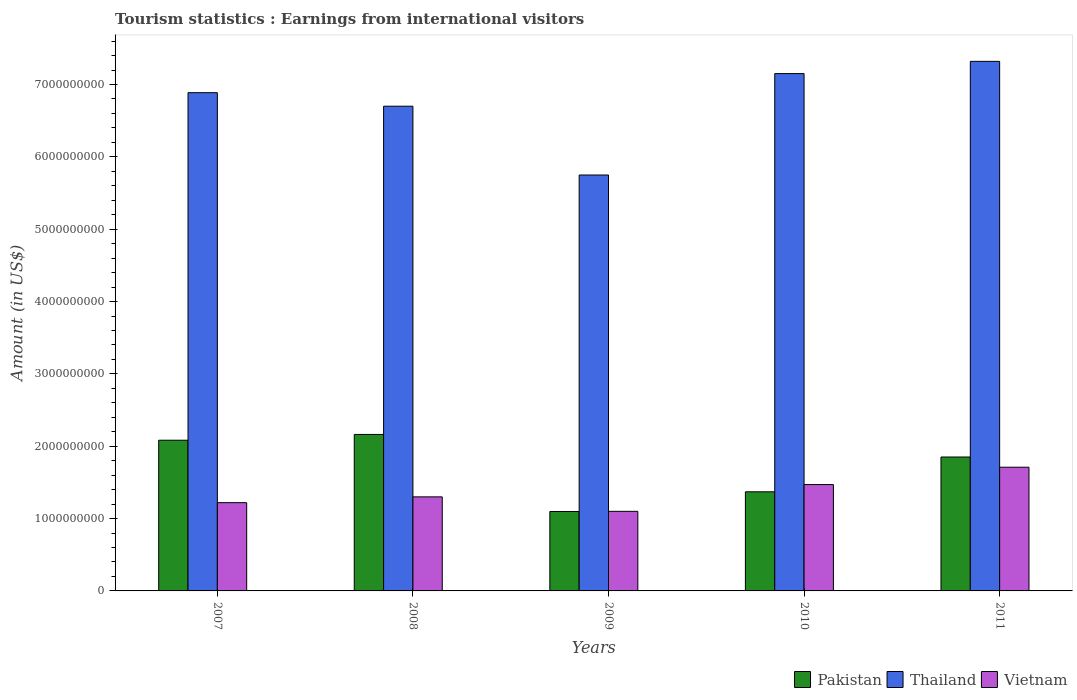How many groups of bars are there?
Your response must be concise. 5. What is the label of the 3rd group of bars from the left?
Your response must be concise. 2009. What is the earnings from international visitors in Pakistan in 2008?
Give a very brief answer. 2.16e+09. Across all years, what is the maximum earnings from international visitors in Thailand?
Ensure brevity in your answer.  7.32e+09. Across all years, what is the minimum earnings from international visitors in Pakistan?
Your response must be concise. 1.10e+09. In which year was the earnings from international visitors in Pakistan maximum?
Offer a terse response. 2008. What is the total earnings from international visitors in Pakistan in the graph?
Keep it short and to the point. 8.56e+09. What is the difference between the earnings from international visitors in Vietnam in 2010 and that in 2011?
Your answer should be very brief. -2.40e+08. What is the difference between the earnings from international visitors in Thailand in 2008 and the earnings from international visitors in Pakistan in 2007?
Ensure brevity in your answer.  4.62e+09. What is the average earnings from international visitors in Vietnam per year?
Provide a short and direct response. 1.36e+09. In the year 2009, what is the difference between the earnings from international visitors in Vietnam and earnings from international visitors in Thailand?
Your answer should be compact. -4.65e+09. In how many years, is the earnings from international visitors in Thailand greater than 3800000000 US$?
Offer a very short reply. 5. What is the ratio of the earnings from international visitors in Vietnam in 2009 to that in 2010?
Provide a succinct answer. 0.75. Is the earnings from international visitors in Pakistan in 2007 less than that in 2010?
Your answer should be compact. No. What is the difference between the highest and the second highest earnings from international visitors in Thailand?
Keep it short and to the point. 1.69e+08. What is the difference between the highest and the lowest earnings from international visitors in Pakistan?
Provide a short and direct response. 1.06e+09. In how many years, is the earnings from international visitors in Thailand greater than the average earnings from international visitors in Thailand taken over all years?
Give a very brief answer. 3. Is the sum of the earnings from international visitors in Pakistan in 2007 and 2011 greater than the maximum earnings from international visitors in Vietnam across all years?
Your answer should be very brief. Yes. What does the 3rd bar from the left in 2011 represents?
Ensure brevity in your answer.  Vietnam. What does the 1st bar from the right in 2011 represents?
Keep it short and to the point. Vietnam. Is it the case that in every year, the sum of the earnings from international visitors in Vietnam and earnings from international visitors in Pakistan is greater than the earnings from international visitors in Thailand?
Provide a succinct answer. No. How many years are there in the graph?
Your answer should be very brief. 5. Does the graph contain any zero values?
Your response must be concise. No. How many legend labels are there?
Offer a terse response. 3. How are the legend labels stacked?
Your answer should be compact. Horizontal. What is the title of the graph?
Ensure brevity in your answer.  Tourism statistics : Earnings from international visitors. Does "Macao" appear as one of the legend labels in the graph?
Offer a very short reply. No. What is the label or title of the X-axis?
Give a very brief answer. Years. What is the label or title of the Y-axis?
Provide a succinct answer. Amount (in US$). What is the Amount (in US$) of Pakistan in 2007?
Give a very brief answer. 2.08e+09. What is the Amount (in US$) of Thailand in 2007?
Provide a succinct answer. 6.89e+09. What is the Amount (in US$) of Vietnam in 2007?
Keep it short and to the point. 1.22e+09. What is the Amount (in US$) of Pakistan in 2008?
Provide a succinct answer. 2.16e+09. What is the Amount (in US$) in Thailand in 2008?
Ensure brevity in your answer.  6.70e+09. What is the Amount (in US$) in Vietnam in 2008?
Offer a terse response. 1.30e+09. What is the Amount (in US$) in Pakistan in 2009?
Your response must be concise. 1.10e+09. What is the Amount (in US$) in Thailand in 2009?
Make the answer very short. 5.75e+09. What is the Amount (in US$) in Vietnam in 2009?
Ensure brevity in your answer.  1.10e+09. What is the Amount (in US$) in Pakistan in 2010?
Keep it short and to the point. 1.37e+09. What is the Amount (in US$) of Thailand in 2010?
Make the answer very short. 7.15e+09. What is the Amount (in US$) of Vietnam in 2010?
Provide a short and direct response. 1.47e+09. What is the Amount (in US$) in Pakistan in 2011?
Your response must be concise. 1.85e+09. What is the Amount (in US$) in Thailand in 2011?
Your answer should be compact. 7.32e+09. What is the Amount (in US$) of Vietnam in 2011?
Give a very brief answer. 1.71e+09. Across all years, what is the maximum Amount (in US$) in Pakistan?
Keep it short and to the point. 2.16e+09. Across all years, what is the maximum Amount (in US$) of Thailand?
Your answer should be very brief. 7.32e+09. Across all years, what is the maximum Amount (in US$) of Vietnam?
Your response must be concise. 1.71e+09. Across all years, what is the minimum Amount (in US$) of Pakistan?
Make the answer very short. 1.10e+09. Across all years, what is the minimum Amount (in US$) of Thailand?
Your response must be concise. 5.75e+09. Across all years, what is the minimum Amount (in US$) in Vietnam?
Your answer should be compact. 1.10e+09. What is the total Amount (in US$) in Pakistan in the graph?
Make the answer very short. 8.56e+09. What is the total Amount (in US$) of Thailand in the graph?
Provide a short and direct response. 3.38e+1. What is the total Amount (in US$) in Vietnam in the graph?
Provide a short and direct response. 6.80e+09. What is the difference between the Amount (in US$) of Pakistan in 2007 and that in 2008?
Your answer should be very brief. -8.00e+07. What is the difference between the Amount (in US$) of Thailand in 2007 and that in 2008?
Your response must be concise. 1.87e+08. What is the difference between the Amount (in US$) of Vietnam in 2007 and that in 2008?
Offer a very short reply. -8.00e+07. What is the difference between the Amount (in US$) of Pakistan in 2007 and that in 2009?
Provide a short and direct response. 9.85e+08. What is the difference between the Amount (in US$) of Thailand in 2007 and that in 2009?
Offer a terse response. 1.14e+09. What is the difference between the Amount (in US$) of Vietnam in 2007 and that in 2009?
Ensure brevity in your answer.  1.20e+08. What is the difference between the Amount (in US$) in Pakistan in 2007 and that in 2010?
Make the answer very short. 7.13e+08. What is the difference between the Amount (in US$) of Thailand in 2007 and that in 2010?
Your answer should be very brief. -2.64e+08. What is the difference between the Amount (in US$) in Vietnam in 2007 and that in 2010?
Ensure brevity in your answer.  -2.50e+08. What is the difference between the Amount (in US$) of Pakistan in 2007 and that in 2011?
Provide a short and direct response. 2.32e+08. What is the difference between the Amount (in US$) in Thailand in 2007 and that in 2011?
Provide a succinct answer. -4.33e+08. What is the difference between the Amount (in US$) in Vietnam in 2007 and that in 2011?
Provide a short and direct response. -4.90e+08. What is the difference between the Amount (in US$) in Pakistan in 2008 and that in 2009?
Keep it short and to the point. 1.06e+09. What is the difference between the Amount (in US$) in Thailand in 2008 and that in 2009?
Ensure brevity in your answer.  9.51e+08. What is the difference between the Amount (in US$) in Vietnam in 2008 and that in 2009?
Your answer should be very brief. 2.00e+08. What is the difference between the Amount (in US$) in Pakistan in 2008 and that in 2010?
Your answer should be compact. 7.93e+08. What is the difference between the Amount (in US$) in Thailand in 2008 and that in 2010?
Your response must be concise. -4.51e+08. What is the difference between the Amount (in US$) in Vietnam in 2008 and that in 2010?
Ensure brevity in your answer.  -1.70e+08. What is the difference between the Amount (in US$) of Pakistan in 2008 and that in 2011?
Provide a short and direct response. 3.12e+08. What is the difference between the Amount (in US$) in Thailand in 2008 and that in 2011?
Keep it short and to the point. -6.20e+08. What is the difference between the Amount (in US$) of Vietnam in 2008 and that in 2011?
Your response must be concise. -4.10e+08. What is the difference between the Amount (in US$) of Pakistan in 2009 and that in 2010?
Offer a very short reply. -2.72e+08. What is the difference between the Amount (in US$) in Thailand in 2009 and that in 2010?
Ensure brevity in your answer.  -1.40e+09. What is the difference between the Amount (in US$) of Vietnam in 2009 and that in 2010?
Provide a succinct answer. -3.70e+08. What is the difference between the Amount (in US$) of Pakistan in 2009 and that in 2011?
Your response must be concise. -7.53e+08. What is the difference between the Amount (in US$) in Thailand in 2009 and that in 2011?
Your answer should be compact. -1.57e+09. What is the difference between the Amount (in US$) in Vietnam in 2009 and that in 2011?
Offer a very short reply. -6.10e+08. What is the difference between the Amount (in US$) of Pakistan in 2010 and that in 2011?
Keep it short and to the point. -4.81e+08. What is the difference between the Amount (in US$) in Thailand in 2010 and that in 2011?
Offer a very short reply. -1.69e+08. What is the difference between the Amount (in US$) in Vietnam in 2010 and that in 2011?
Provide a succinct answer. -2.40e+08. What is the difference between the Amount (in US$) of Pakistan in 2007 and the Amount (in US$) of Thailand in 2008?
Provide a succinct answer. -4.62e+09. What is the difference between the Amount (in US$) in Pakistan in 2007 and the Amount (in US$) in Vietnam in 2008?
Keep it short and to the point. 7.83e+08. What is the difference between the Amount (in US$) of Thailand in 2007 and the Amount (in US$) of Vietnam in 2008?
Your answer should be very brief. 5.59e+09. What is the difference between the Amount (in US$) of Pakistan in 2007 and the Amount (in US$) of Thailand in 2009?
Your response must be concise. -3.67e+09. What is the difference between the Amount (in US$) of Pakistan in 2007 and the Amount (in US$) of Vietnam in 2009?
Your response must be concise. 9.83e+08. What is the difference between the Amount (in US$) of Thailand in 2007 and the Amount (in US$) of Vietnam in 2009?
Give a very brief answer. 5.79e+09. What is the difference between the Amount (in US$) of Pakistan in 2007 and the Amount (in US$) of Thailand in 2010?
Provide a short and direct response. -5.07e+09. What is the difference between the Amount (in US$) in Pakistan in 2007 and the Amount (in US$) in Vietnam in 2010?
Offer a very short reply. 6.13e+08. What is the difference between the Amount (in US$) in Thailand in 2007 and the Amount (in US$) in Vietnam in 2010?
Ensure brevity in your answer.  5.42e+09. What is the difference between the Amount (in US$) of Pakistan in 2007 and the Amount (in US$) of Thailand in 2011?
Provide a short and direct response. -5.24e+09. What is the difference between the Amount (in US$) of Pakistan in 2007 and the Amount (in US$) of Vietnam in 2011?
Give a very brief answer. 3.73e+08. What is the difference between the Amount (in US$) of Thailand in 2007 and the Amount (in US$) of Vietnam in 2011?
Ensure brevity in your answer.  5.18e+09. What is the difference between the Amount (in US$) in Pakistan in 2008 and the Amount (in US$) in Thailand in 2009?
Provide a short and direct response. -3.59e+09. What is the difference between the Amount (in US$) in Pakistan in 2008 and the Amount (in US$) in Vietnam in 2009?
Offer a very short reply. 1.06e+09. What is the difference between the Amount (in US$) in Thailand in 2008 and the Amount (in US$) in Vietnam in 2009?
Your answer should be very brief. 5.60e+09. What is the difference between the Amount (in US$) of Pakistan in 2008 and the Amount (in US$) of Thailand in 2010?
Provide a succinct answer. -4.99e+09. What is the difference between the Amount (in US$) of Pakistan in 2008 and the Amount (in US$) of Vietnam in 2010?
Offer a terse response. 6.93e+08. What is the difference between the Amount (in US$) in Thailand in 2008 and the Amount (in US$) in Vietnam in 2010?
Offer a terse response. 5.23e+09. What is the difference between the Amount (in US$) in Pakistan in 2008 and the Amount (in US$) in Thailand in 2011?
Offer a terse response. -5.16e+09. What is the difference between the Amount (in US$) of Pakistan in 2008 and the Amount (in US$) of Vietnam in 2011?
Provide a short and direct response. 4.53e+08. What is the difference between the Amount (in US$) in Thailand in 2008 and the Amount (in US$) in Vietnam in 2011?
Your response must be concise. 4.99e+09. What is the difference between the Amount (in US$) in Pakistan in 2009 and the Amount (in US$) in Thailand in 2010?
Offer a very short reply. -6.05e+09. What is the difference between the Amount (in US$) in Pakistan in 2009 and the Amount (in US$) in Vietnam in 2010?
Provide a short and direct response. -3.72e+08. What is the difference between the Amount (in US$) of Thailand in 2009 and the Amount (in US$) of Vietnam in 2010?
Give a very brief answer. 4.28e+09. What is the difference between the Amount (in US$) of Pakistan in 2009 and the Amount (in US$) of Thailand in 2011?
Offer a very short reply. -6.22e+09. What is the difference between the Amount (in US$) of Pakistan in 2009 and the Amount (in US$) of Vietnam in 2011?
Make the answer very short. -6.12e+08. What is the difference between the Amount (in US$) in Thailand in 2009 and the Amount (in US$) in Vietnam in 2011?
Make the answer very short. 4.04e+09. What is the difference between the Amount (in US$) of Pakistan in 2010 and the Amount (in US$) of Thailand in 2011?
Your answer should be compact. -5.95e+09. What is the difference between the Amount (in US$) of Pakistan in 2010 and the Amount (in US$) of Vietnam in 2011?
Give a very brief answer. -3.40e+08. What is the difference between the Amount (in US$) of Thailand in 2010 and the Amount (in US$) of Vietnam in 2011?
Ensure brevity in your answer.  5.44e+09. What is the average Amount (in US$) of Pakistan per year?
Offer a terse response. 1.71e+09. What is the average Amount (in US$) in Thailand per year?
Give a very brief answer. 6.76e+09. What is the average Amount (in US$) in Vietnam per year?
Provide a succinct answer. 1.36e+09. In the year 2007, what is the difference between the Amount (in US$) in Pakistan and Amount (in US$) in Thailand?
Offer a terse response. -4.80e+09. In the year 2007, what is the difference between the Amount (in US$) of Pakistan and Amount (in US$) of Vietnam?
Your answer should be very brief. 8.63e+08. In the year 2007, what is the difference between the Amount (in US$) in Thailand and Amount (in US$) in Vietnam?
Make the answer very short. 5.67e+09. In the year 2008, what is the difference between the Amount (in US$) of Pakistan and Amount (in US$) of Thailand?
Your answer should be very brief. -4.54e+09. In the year 2008, what is the difference between the Amount (in US$) of Pakistan and Amount (in US$) of Vietnam?
Your answer should be very brief. 8.63e+08. In the year 2008, what is the difference between the Amount (in US$) in Thailand and Amount (in US$) in Vietnam?
Your answer should be very brief. 5.40e+09. In the year 2009, what is the difference between the Amount (in US$) in Pakistan and Amount (in US$) in Thailand?
Offer a very short reply. -4.65e+09. In the year 2009, what is the difference between the Amount (in US$) in Thailand and Amount (in US$) in Vietnam?
Your response must be concise. 4.65e+09. In the year 2010, what is the difference between the Amount (in US$) in Pakistan and Amount (in US$) in Thailand?
Your answer should be compact. -5.78e+09. In the year 2010, what is the difference between the Amount (in US$) in Pakistan and Amount (in US$) in Vietnam?
Keep it short and to the point. -1.00e+08. In the year 2010, what is the difference between the Amount (in US$) of Thailand and Amount (in US$) of Vietnam?
Ensure brevity in your answer.  5.68e+09. In the year 2011, what is the difference between the Amount (in US$) of Pakistan and Amount (in US$) of Thailand?
Keep it short and to the point. -5.47e+09. In the year 2011, what is the difference between the Amount (in US$) in Pakistan and Amount (in US$) in Vietnam?
Your answer should be compact. 1.41e+08. In the year 2011, what is the difference between the Amount (in US$) of Thailand and Amount (in US$) of Vietnam?
Your response must be concise. 5.61e+09. What is the ratio of the Amount (in US$) in Thailand in 2007 to that in 2008?
Your response must be concise. 1.03. What is the ratio of the Amount (in US$) of Vietnam in 2007 to that in 2008?
Keep it short and to the point. 0.94. What is the ratio of the Amount (in US$) in Pakistan in 2007 to that in 2009?
Give a very brief answer. 1.9. What is the ratio of the Amount (in US$) in Thailand in 2007 to that in 2009?
Provide a succinct answer. 1.2. What is the ratio of the Amount (in US$) in Vietnam in 2007 to that in 2009?
Ensure brevity in your answer.  1.11. What is the ratio of the Amount (in US$) in Pakistan in 2007 to that in 2010?
Offer a terse response. 1.52. What is the ratio of the Amount (in US$) of Thailand in 2007 to that in 2010?
Your answer should be very brief. 0.96. What is the ratio of the Amount (in US$) in Vietnam in 2007 to that in 2010?
Keep it short and to the point. 0.83. What is the ratio of the Amount (in US$) of Pakistan in 2007 to that in 2011?
Offer a terse response. 1.13. What is the ratio of the Amount (in US$) of Thailand in 2007 to that in 2011?
Give a very brief answer. 0.94. What is the ratio of the Amount (in US$) of Vietnam in 2007 to that in 2011?
Make the answer very short. 0.71. What is the ratio of the Amount (in US$) of Pakistan in 2008 to that in 2009?
Provide a short and direct response. 1.97. What is the ratio of the Amount (in US$) in Thailand in 2008 to that in 2009?
Your answer should be very brief. 1.17. What is the ratio of the Amount (in US$) of Vietnam in 2008 to that in 2009?
Offer a terse response. 1.18. What is the ratio of the Amount (in US$) of Pakistan in 2008 to that in 2010?
Ensure brevity in your answer.  1.58. What is the ratio of the Amount (in US$) in Thailand in 2008 to that in 2010?
Provide a short and direct response. 0.94. What is the ratio of the Amount (in US$) in Vietnam in 2008 to that in 2010?
Offer a terse response. 0.88. What is the ratio of the Amount (in US$) of Pakistan in 2008 to that in 2011?
Provide a short and direct response. 1.17. What is the ratio of the Amount (in US$) in Thailand in 2008 to that in 2011?
Offer a terse response. 0.92. What is the ratio of the Amount (in US$) in Vietnam in 2008 to that in 2011?
Make the answer very short. 0.76. What is the ratio of the Amount (in US$) of Pakistan in 2009 to that in 2010?
Your response must be concise. 0.8. What is the ratio of the Amount (in US$) of Thailand in 2009 to that in 2010?
Your answer should be compact. 0.8. What is the ratio of the Amount (in US$) of Vietnam in 2009 to that in 2010?
Make the answer very short. 0.75. What is the ratio of the Amount (in US$) of Pakistan in 2009 to that in 2011?
Make the answer very short. 0.59. What is the ratio of the Amount (in US$) of Thailand in 2009 to that in 2011?
Give a very brief answer. 0.79. What is the ratio of the Amount (in US$) in Vietnam in 2009 to that in 2011?
Make the answer very short. 0.64. What is the ratio of the Amount (in US$) in Pakistan in 2010 to that in 2011?
Offer a terse response. 0.74. What is the ratio of the Amount (in US$) in Thailand in 2010 to that in 2011?
Make the answer very short. 0.98. What is the ratio of the Amount (in US$) in Vietnam in 2010 to that in 2011?
Your answer should be very brief. 0.86. What is the difference between the highest and the second highest Amount (in US$) in Pakistan?
Make the answer very short. 8.00e+07. What is the difference between the highest and the second highest Amount (in US$) in Thailand?
Ensure brevity in your answer.  1.69e+08. What is the difference between the highest and the second highest Amount (in US$) in Vietnam?
Give a very brief answer. 2.40e+08. What is the difference between the highest and the lowest Amount (in US$) in Pakistan?
Your answer should be compact. 1.06e+09. What is the difference between the highest and the lowest Amount (in US$) of Thailand?
Your response must be concise. 1.57e+09. What is the difference between the highest and the lowest Amount (in US$) of Vietnam?
Offer a very short reply. 6.10e+08. 